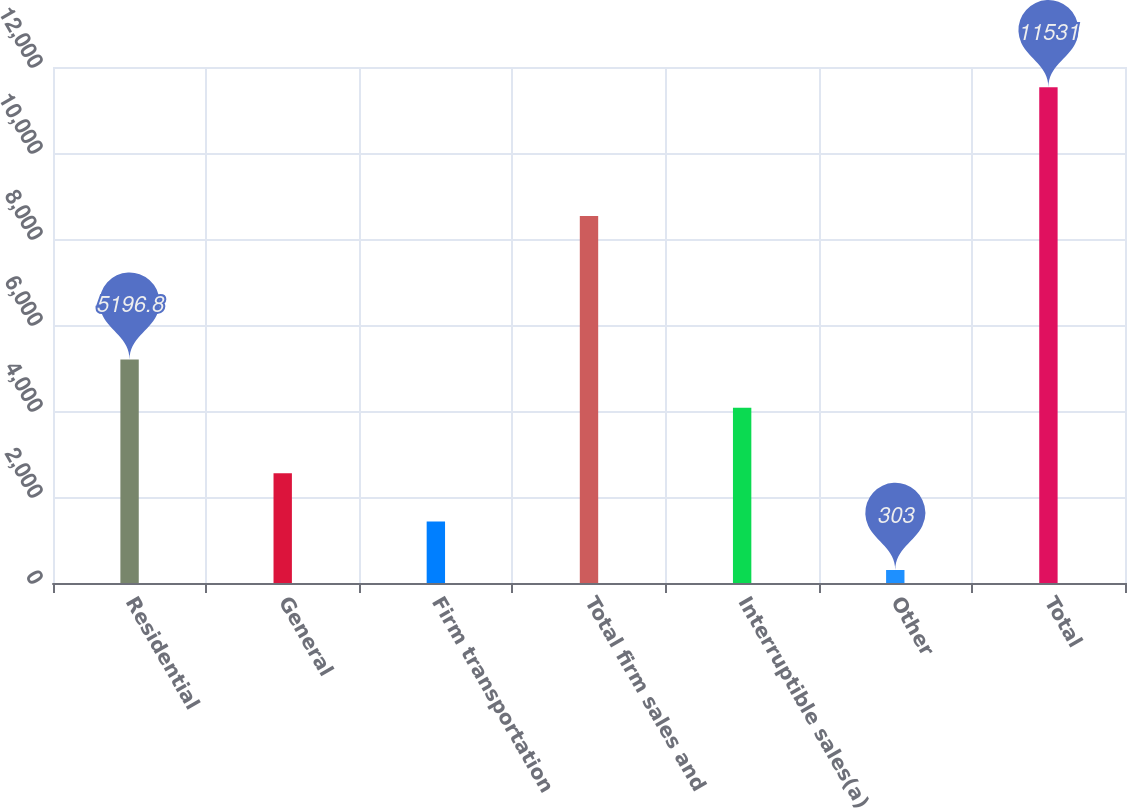<chart> <loc_0><loc_0><loc_500><loc_500><bar_chart><fcel>Residential<fcel>General<fcel>Firm transportation<fcel>Total firm sales and<fcel>Interruptible sales(a)<fcel>Other<fcel>Total<nl><fcel>5196.8<fcel>2553.8<fcel>1431<fcel>8532<fcel>4074<fcel>303<fcel>11531<nl></chart> 